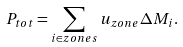<formula> <loc_0><loc_0><loc_500><loc_500>P _ { t o t } = \sum _ { i \in z o n e s } u _ { z o n e } \Delta M _ { i } .</formula> 